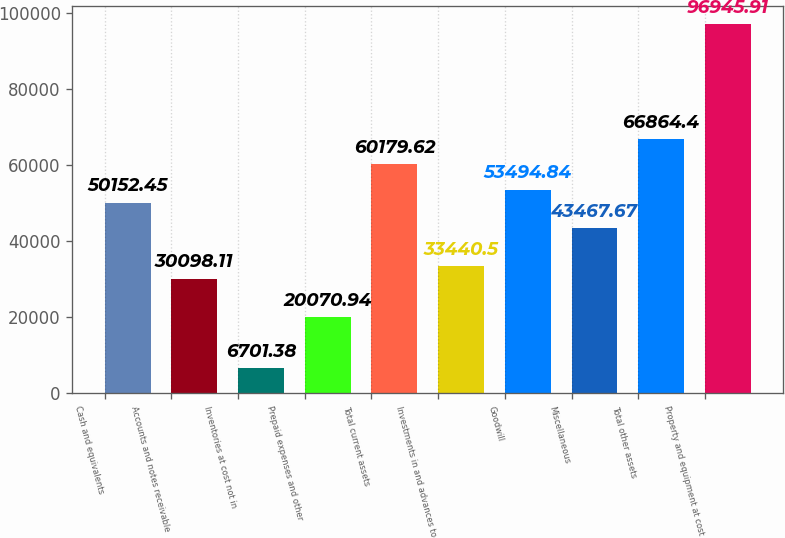<chart> <loc_0><loc_0><loc_500><loc_500><bar_chart><fcel>Cash and equivalents<fcel>Accounts and notes receivable<fcel>Inventories at cost not in<fcel>Prepaid expenses and other<fcel>Total current assets<fcel>Investments in and advances to<fcel>Goodwill<fcel>Miscellaneous<fcel>Total other assets<fcel>Property and equipment at cost<nl><fcel>50152.4<fcel>30098.1<fcel>6701.38<fcel>20070.9<fcel>60179.6<fcel>33440.5<fcel>53494.8<fcel>43467.7<fcel>66864.4<fcel>96945.9<nl></chart> 